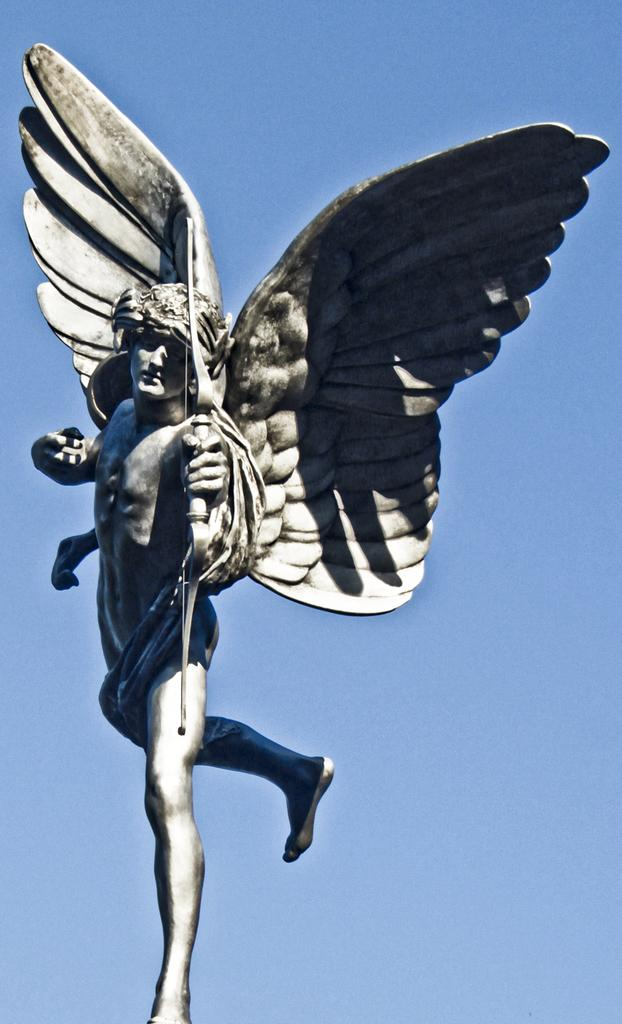What is the main subject of the image? There is a statue in the image. What does the statue resemble? The statue resembles a fairy with wings. What is the statue holding in its hand? The statue is holding an arrow in its hand. What can be seen in the background of the image? There is a sky visible in the background of the image. How many people are in the group that is trying to lift the statue in the image? There is no group of people attempting to lift the statue in the image; it is a static statue of a fairy holding an arrow. 